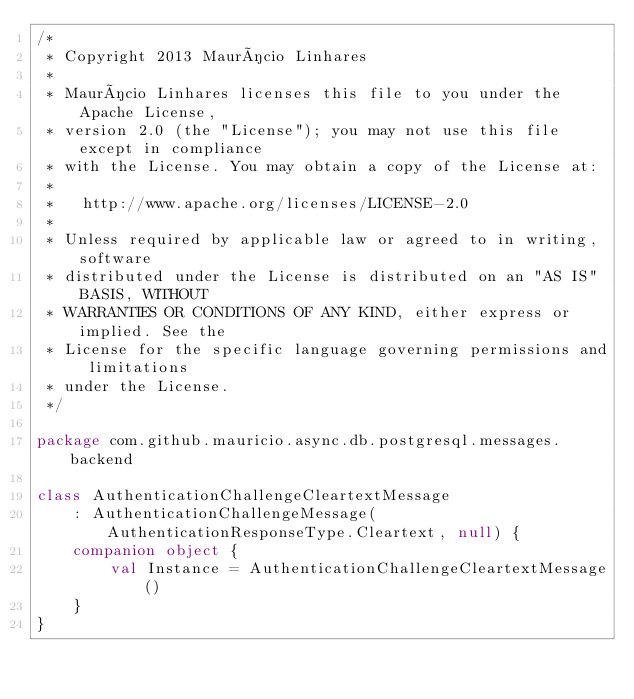<code> <loc_0><loc_0><loc_500><loc_500><_Kotlin_>/*
 * Copyright 2013 Maurício Linhares
 *
 * Maurício Linhares licenses this file to you under the Apache License,
 * version 2.0 (the "License"); you may not use this file except in compliance
 * with the License. You may obtain a copy of the License at:
 *
 *   http://www.apache.org/licenses/LICENSE-2.0
 *
 * Unless required by applicable law or agreed to in writing, software
 * distributed under the License is distributed on an "AS IS" BASIS, WITHOUT
 * WARRANTIES OR CONDITIONS OF ANY KIND, either express or implied. See the
 * License for the specific language governing permissions and limitations
 * under the License.
 */

package com.github.mauricio.async.db.postgresql.messages.backend

class AuthenticationChallengeCleartextMessage
    : AuthenticationChallengeMessage(AuthenticationResponseType.Cleartext, null) {
    companion object {
        val Instance = AuthenticationChallengeCleartextMessage()
    }
}
</code> 